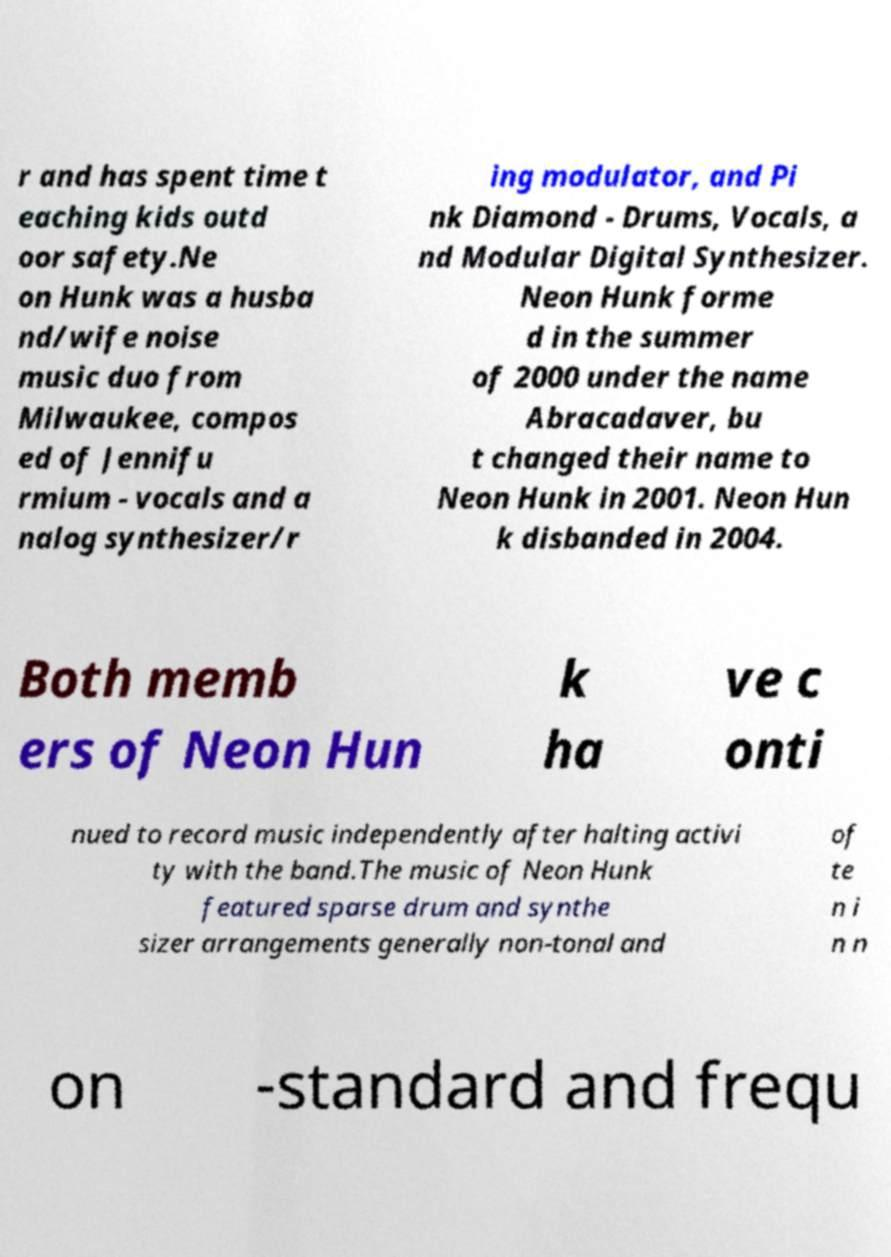Could you assist in decoding the text presented in this image and type it out clearly? r and has spent time t eaching kids outd oor safety.Ne on Hunk was a husba nd/wife noise music duo from Milwaukee, compos ed of Jennifu rmium - vocals and a nalog synthesizer/r ing modulator, and Pi nk Diamond - Drums, Vocals, a nd Modular Digital Synthesizer. Neon Hunk forme d in the summer of 2000 under the name Abracadaver, bu t changed their name to Neon Hunk in 2001. Neon Hun k disbanded in 2004. Both memb ers of Neon Hun k ha ve c onti nued to record music independently after halting activi ty with the band.The music of Neon Hunk featured sparse drum and synthe sizer arrangements generally non-tonal and of te n i n n on -standard and frequ 